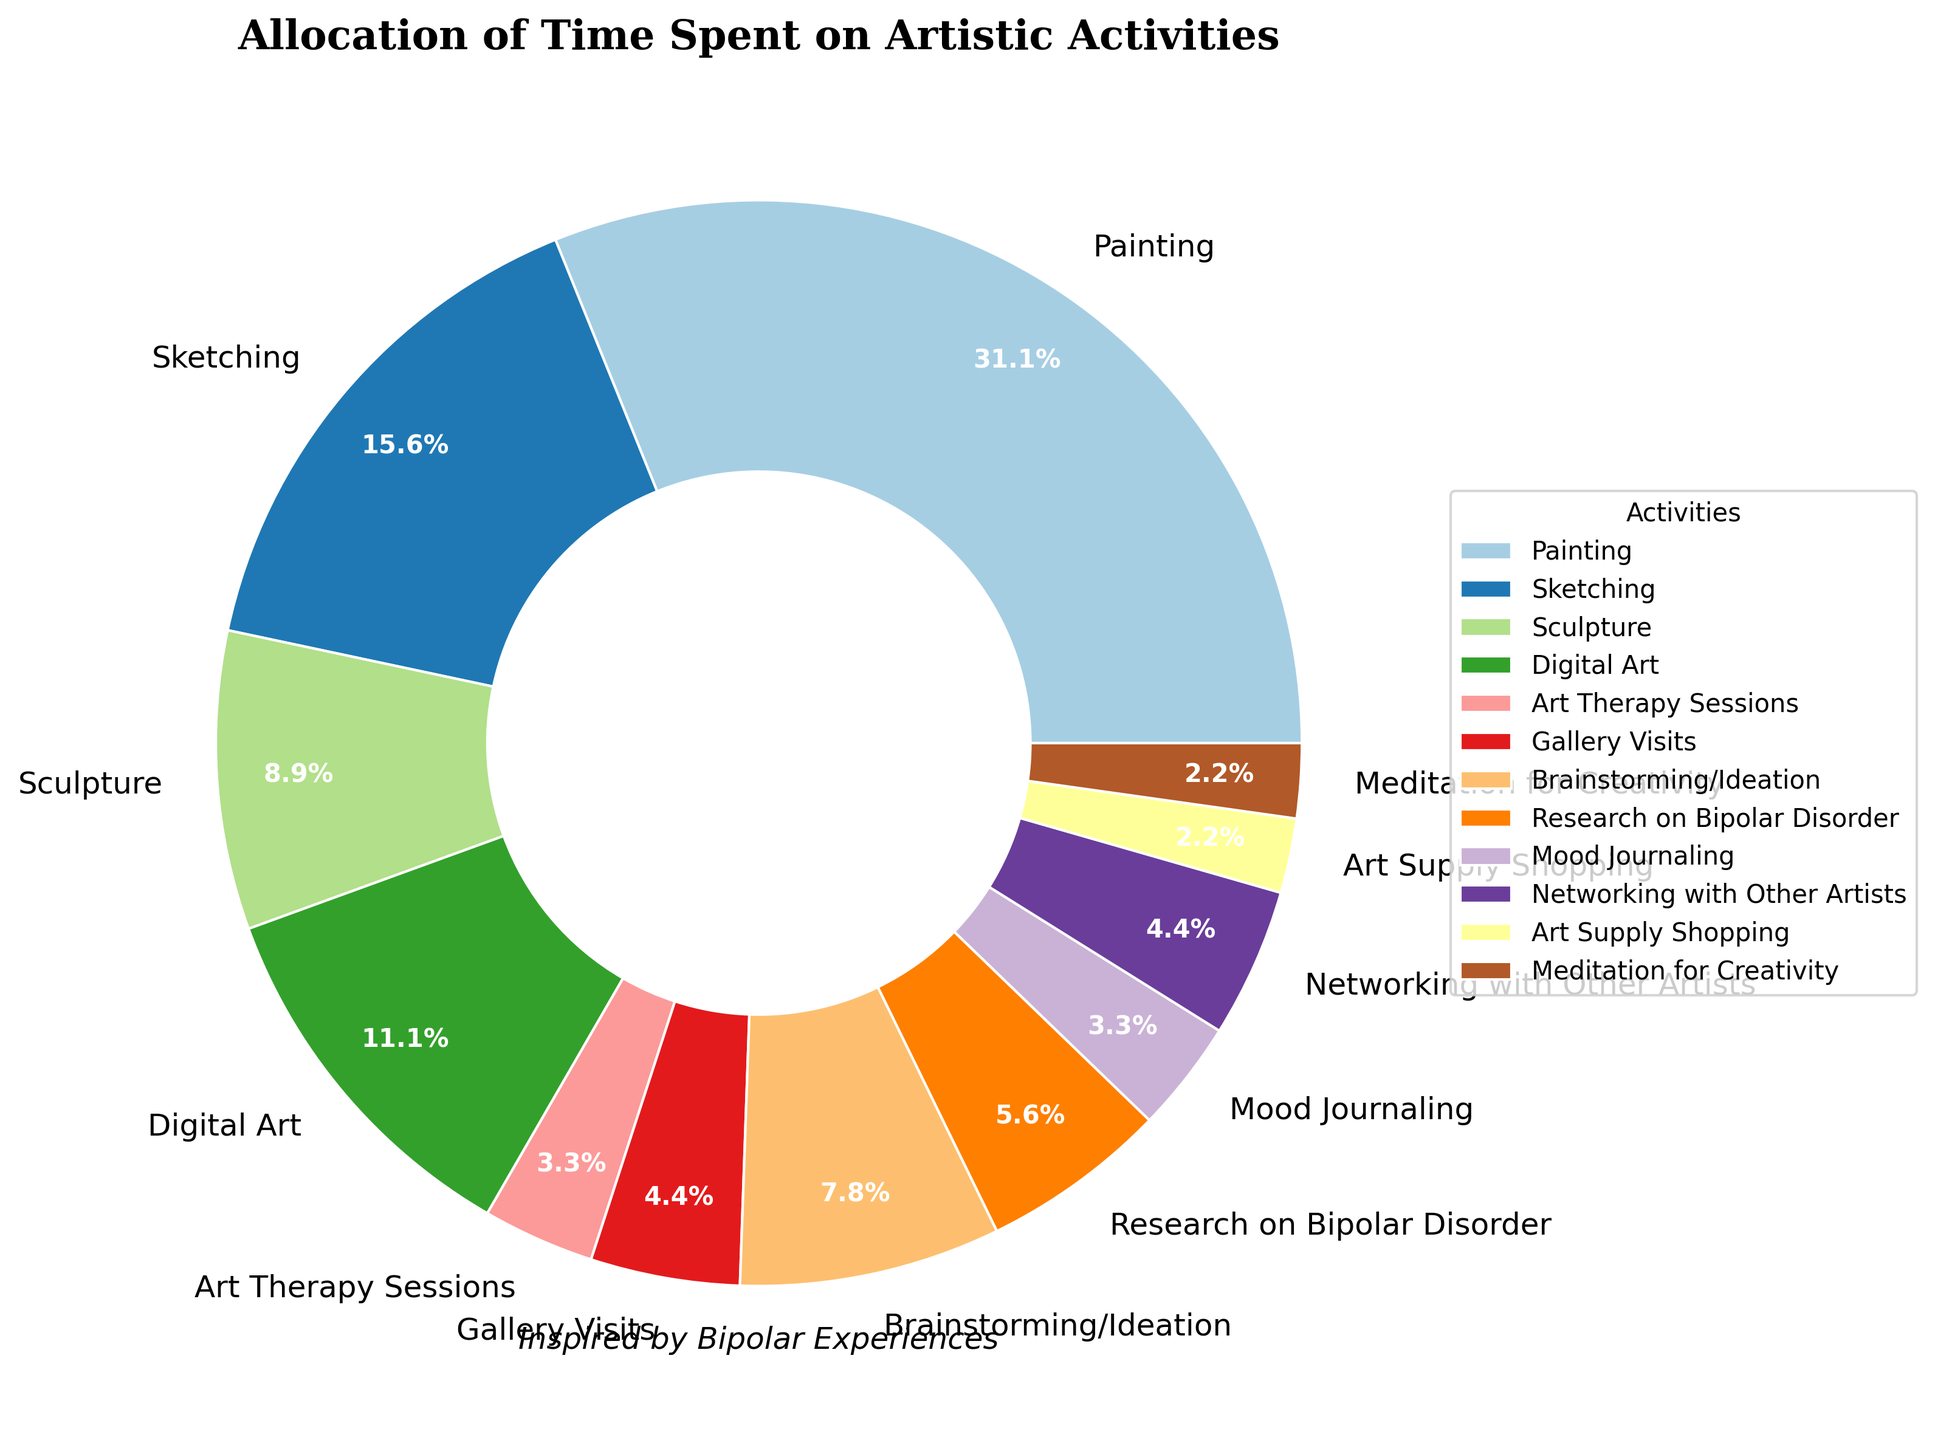What's the total time spent on digital and traditional (painting, sketching, sculpture) art activities per week? Add up the hours for painting, sketching, sculpture, and digital art: 28 (painting) + 14 (sketching) + 8 (sculpture) + 10 (digital art) = 60 hours
Answer: 60 hours Which activity takes up the most time? The activity with the largest percentage of the pie chart is painting, which amounts to 28 hours per week
Answer: Painting How much more time is spent on painting compared to brainstorming/ideation? Subtract the hours spent on brainstorming/ideation from the hours spent on painting: 28 (painting) - 7 (brainstorming/ideation) = 21 hours
Answer: 21 hours What percentage of time is spent on networking with other artists and gallery visits combined? Combine the percentages of networking with other artists and gallery visits: 4 (networking) + 4 (gallery visits) = 8%. If it's provided as hours: (4+4) / 80 * 100 = 10%
Answer: 10% Is more time spent on sketching or sculpture? Compare the hours spent on sketching and sculpture. Sketching has 14 hours, while sculpture has 8 hours, so more time is spent on sketching
Answer: Sketching What fraction of the time is spent on art therapy sessions compared to total time on all activities? Art therapy sessions take 3 hours. The total time spent on all activities is 80 hours. The fraction is 3/80
Answer: 3/80 Which activity occupies the smallest portion of the pie chart? The activity that occupies the smallest portion is art supply shopping, taking 2 hours per week
Answer: Art supply shopping What's the average time spent on meditation for creativity and mood journaling per week? Add the hours for meditation and mood journaling, then divide by 2: (2 (meditation) + 3 (mood journaling)) / 2 = 2.5 hours
Answer: 2.5 hours How does time spent on research on bipolar disorder compare to time spent on digital art? Compare the hours: Research on bipolar disorder is 5 hours, whereas digital art is 10 hours. Hence, less time is spent on research on bipolar disorder compared to digital art
Answer: Less time What's the combined percentage of time spent on art therapy sessions and mood journaling? Add the percentages of art therapy sessions and mood journaling from the pie chart. If the percentages are not given, use the hours: (3+3) / 80 * 100 = 7.5%
Answer: 7.5% 